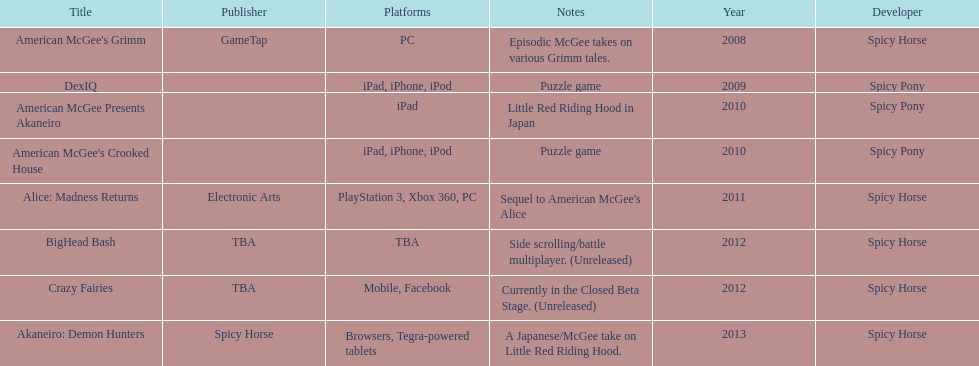What was the last game created by spicy horse Akaneiro: Demon Hunters. 